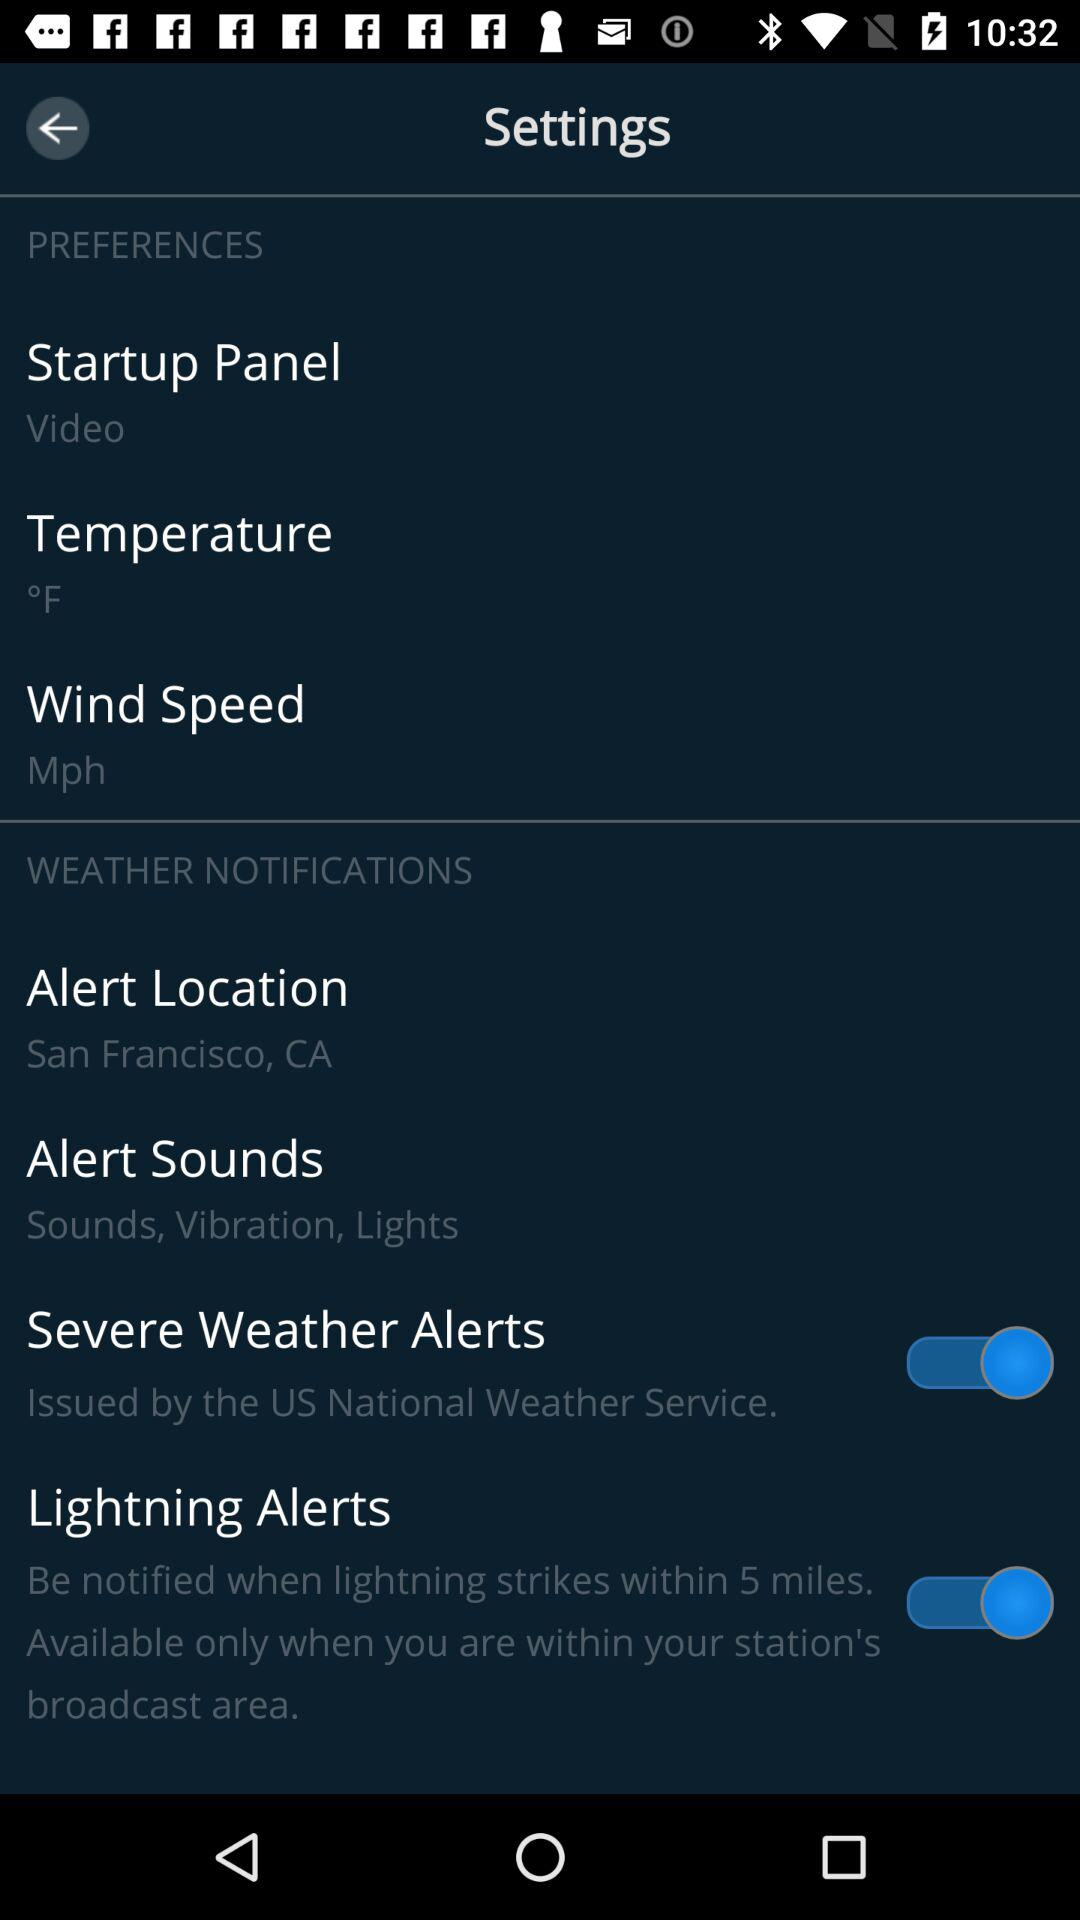How many items in the Weather Notifications section have a switch?
Answer the question using a single word or phrase. 2 